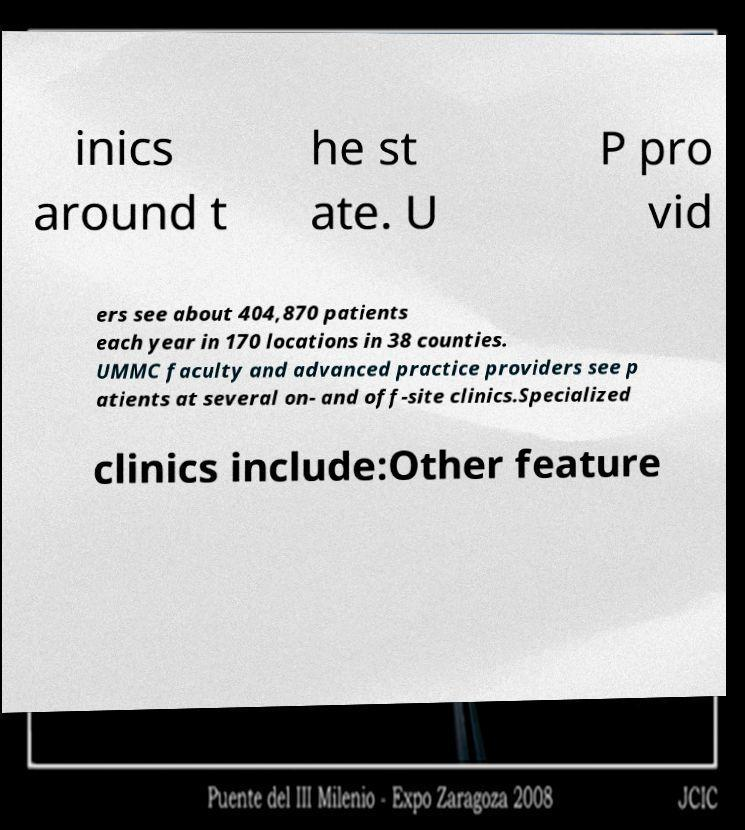Could you extract and type out the text from this image? inics around t he st ate. U P pro vid ers see about 404,870 patients each year in 170 locations in 38 counties. UMMC faculty and advanced practice providers see p atients at several on- and off-site clinics.Specialized clinics include:Other feature 